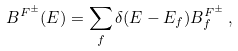<formula> <loc_0><loc_0><loc_500><loc_500>B ^ { F ^ { \pm } } ( E ) = \sum _ { f } \delta ( E - E _ { f } ) B _ { f } ^ { F ^ { \pm } } \, ,</formula> 